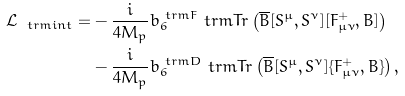Convert formula to latex. <formula><loc_0><loc_0><loc_500><loc_500>\mathcal { L } _ { \ t r m { i n t } } = & - \frac { i } { 4 M _ { p } } b _ { 6 } ^ { \ t r m { F } } \ t r m { T r } \left ( \overline { B } [ S ^ { \mu } , S ^ { \nu } ] [ F _ { \mu \nu } ^ { + } , B ] \right ) \\ & - \frac { i } { 4 M _ { p } } b _ { 6 } ^ { \ t r m { D } } \ t r m { T r } \left ( \overline { B } [ S ^ { \mu } , S ^ { \nu } ] \{ F _ { \mu \nu } ^ { + } , B \} \right ) ,</formula> 